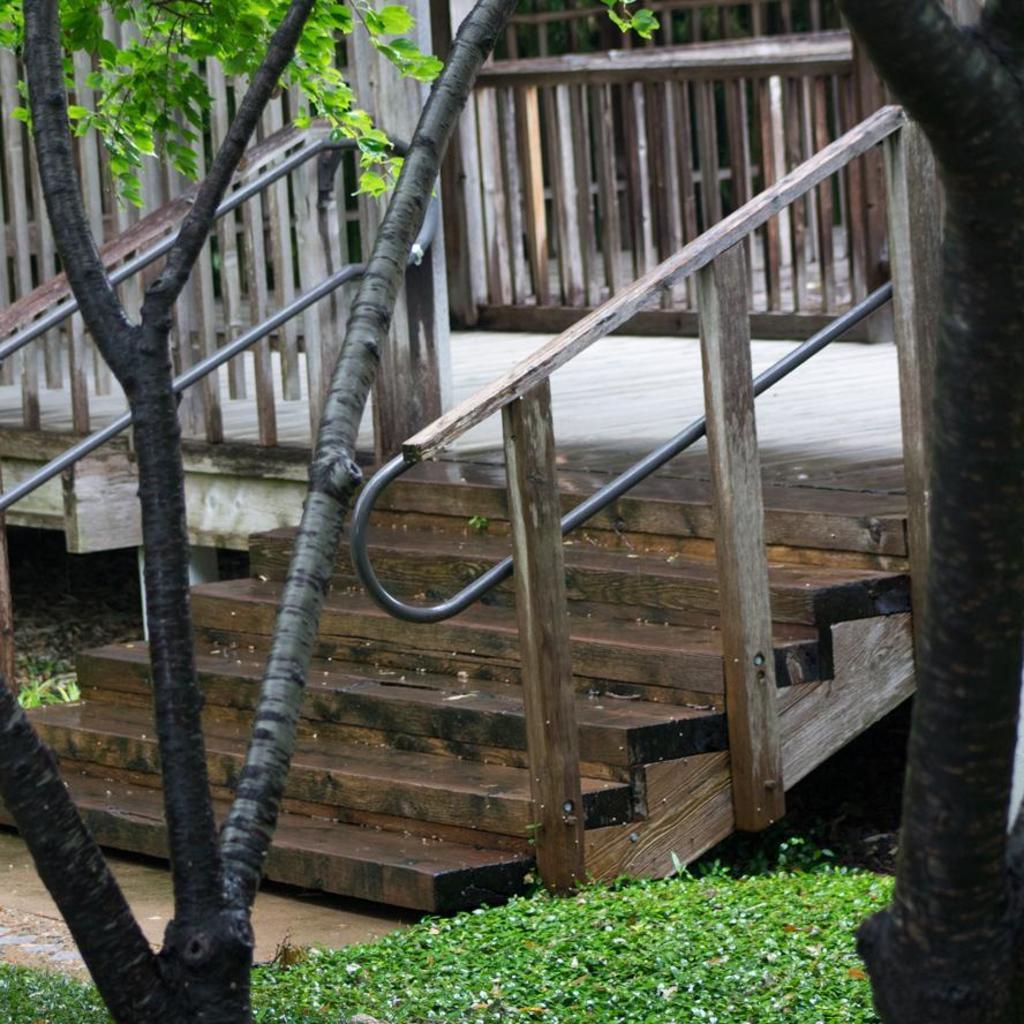Could you give a brief overview of what you see in this image? In this image we can see the stairs of a building, in front of the stairs there are trees and plants. 